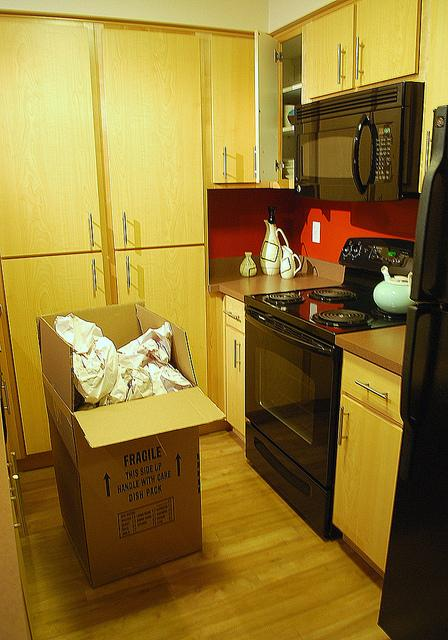What is the top word on the box? Please explain your reasoning. fragile. The letters are plain to see and the first one is f 